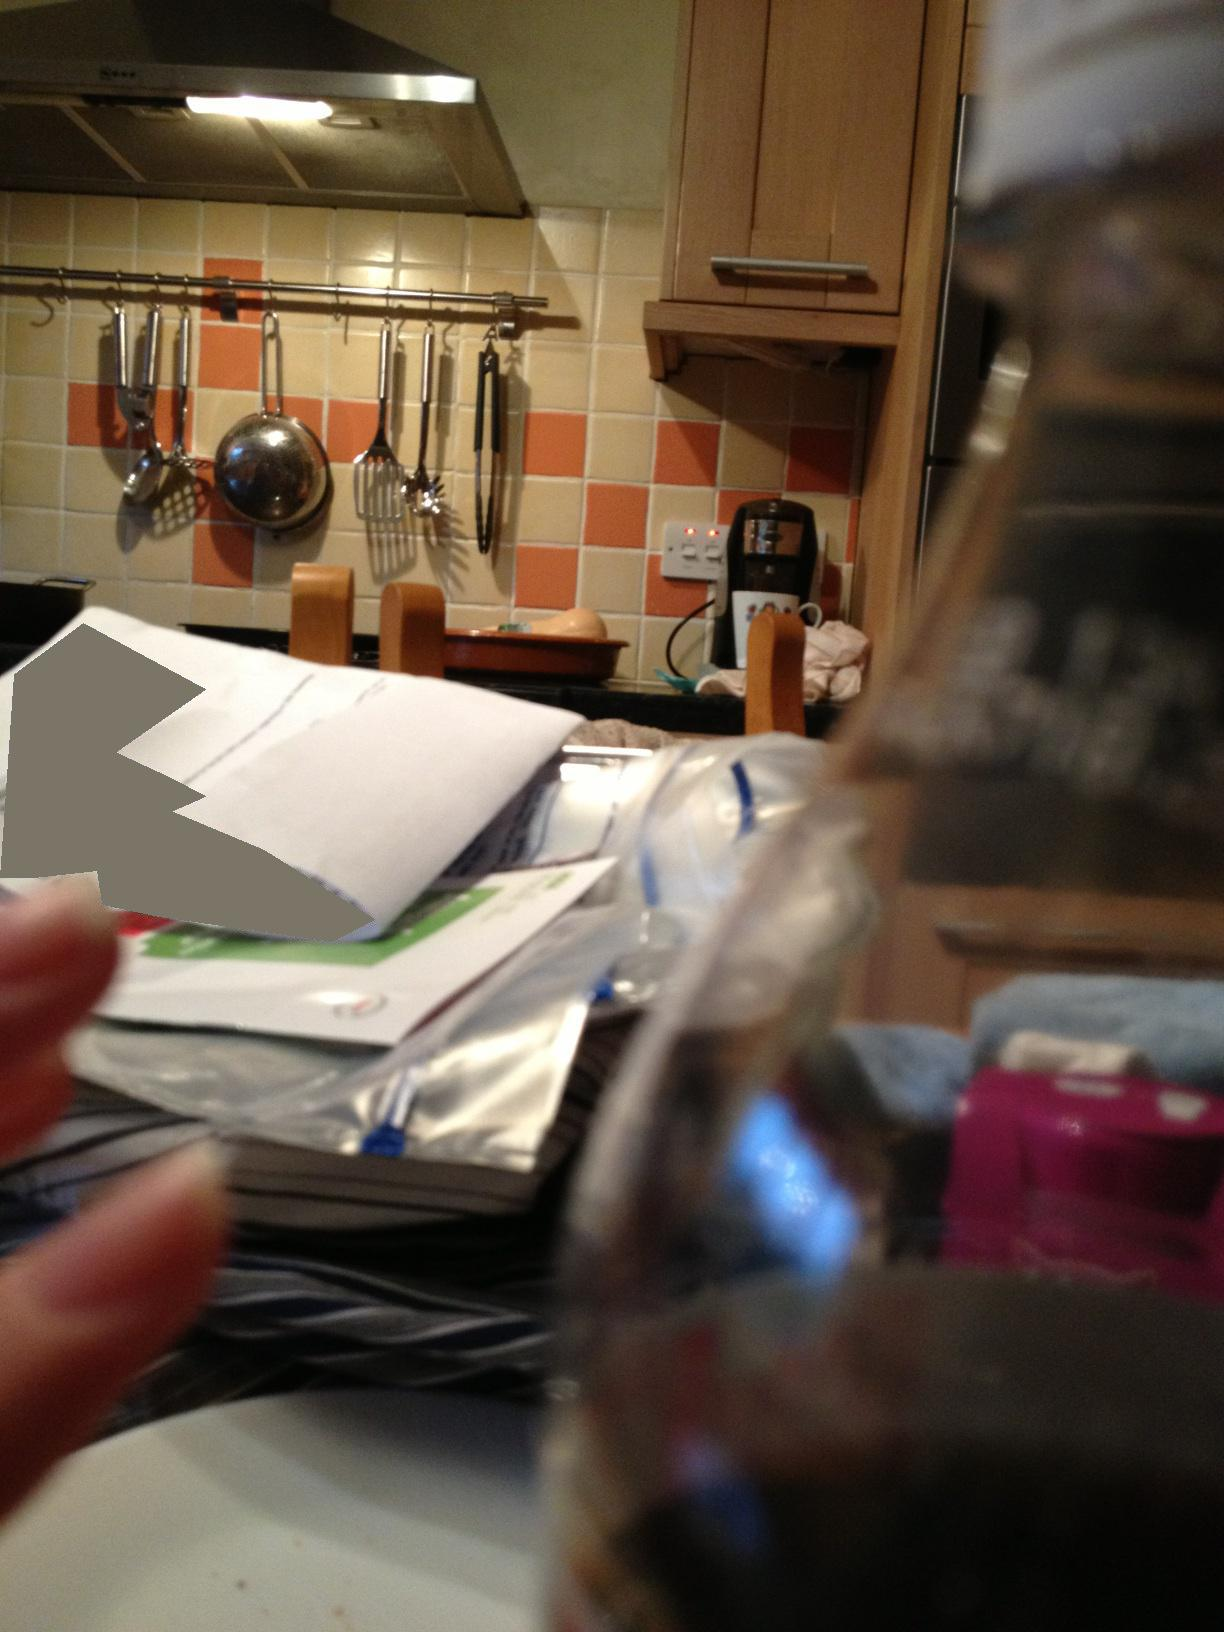What is this? This image depicts a cluttered kitchen counter, which includes numerous items such as paperwork, kitchen utensils hanging on a rack, and various appliances. The focus of the photo is slightly blurred, indicating a candid moment perhaps taken unintentionally. 